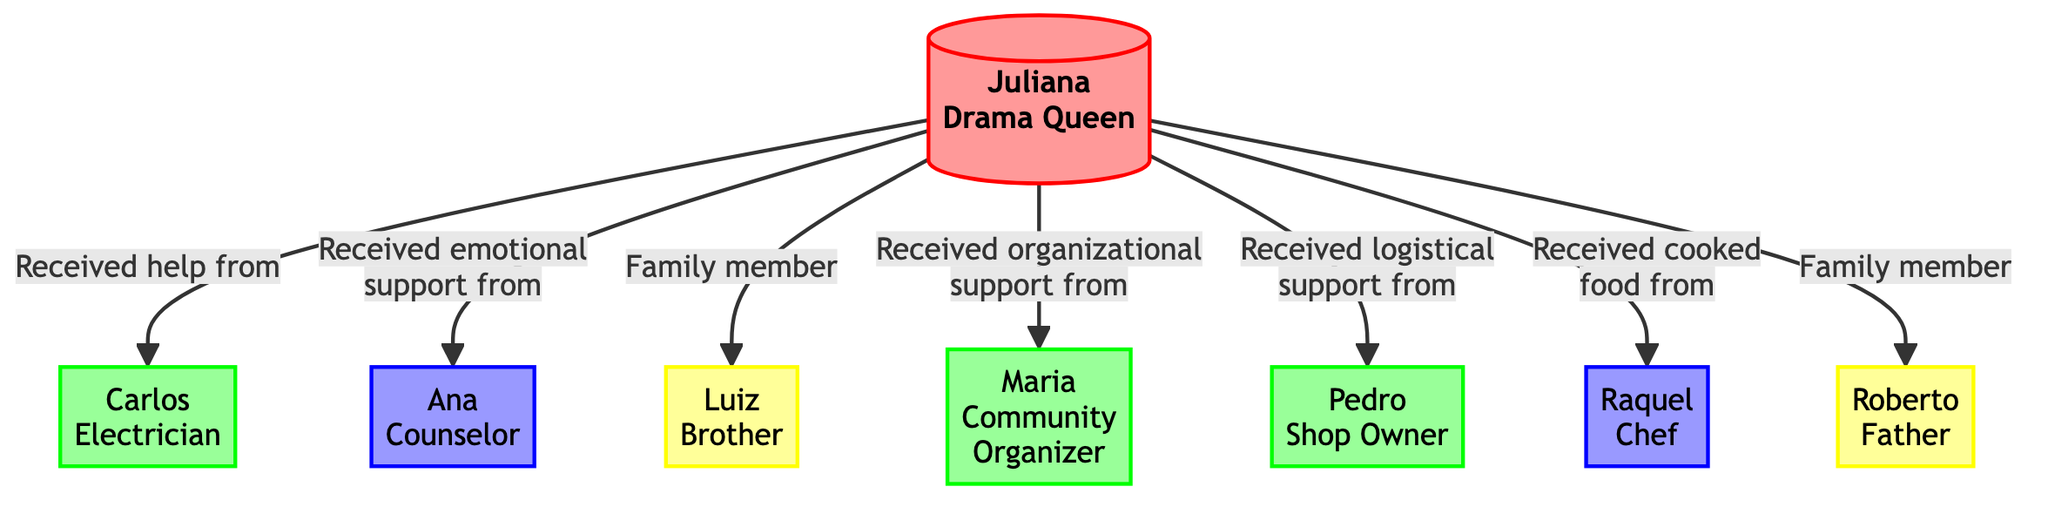What's the total number of nodes in the diagram? The diagram includes a total of 8 nodes, each representing a person involved during the blackout period. These nodes are interconnected to depict various relationships and interactions among them.
Answer: 8 How many edges connect Juliana to others? Juliana is connected to 6 other nodes through edges, indicating the various forms of support she received during the blackout, such as emotional support, organizational help, and food assistance.
Answer: 6 Who provided emotional support to Juliana? The diagram shows that Ana, identified as a counselor, was the one who provided emotional support to Juliana during the blackout, as indicated by the connecting edge.
Answer: Ana What type of help did Carlos provide to Juliana? According to the diagram, the relationship between Juliana and Carlos specifies that Carlos helped Juliana by fixing minor electrical issues, suggesting that his support was technical in nature.
Answer: Technical help Which neighbor organized neighborhood meetings? The diagram clearly indicates that Maria, a community organizer and neighbor, coordinated neighborhood meetings to help manage support efforts during the blackout.
Answer: Maria How many family members are linked to Juliana? The diagram illustrates that there are 2 family members connected to Juliana: her brother Luiz and her father Roberto, both of whom provided assistance in various ways.
Answer: 2 Who cooked meals for the community? Raquel, identified as a chef in the diagram, is the one who cooked meals for the community using her gas stove, providing a crucial support service when electricity was unavailable.
Answer: Raquel What type of support did Pedro offer? The diagram outlines that Pedro, the shop owner, provided logistical support to Juliana by allowing her to use freezer space for perishable goods, highlighting the practical help he offered during the blackout.
Answer: Logistical support What is the relationship label between Juliana and her brother? The relationship label between Juliana and her brother Luiz is simply "Family member," indicating a familial connection as well as their collaborative efforts during the blackout.
Answer: Family member 